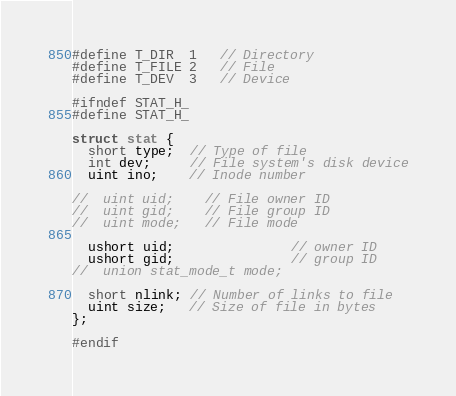Convert code to text. <code><loc_0><loc_0><loc_500><loc_500><_C_>#define T_DIR  1   // Directory
#define T_FILE 2   // File
#define T_DEV  3   // Device

#ifndef STAT_H_
#define STAT_H_

struct stat {
  short type;  // Type of file
  int dev;     // File system's disk device
  uint ino;    // Inode number

//  uint uid;    // File owner ID
//  uint gid;    // File group ID
//  uint mode;   // File mode

  ushort uid;               // owner ID
  ushort gid;               // group ID
//  union stat_mode_t mode;

  short nlink; // Number of links to file
  uint size;   // Size of file in bytes
};

#endif
</code> 